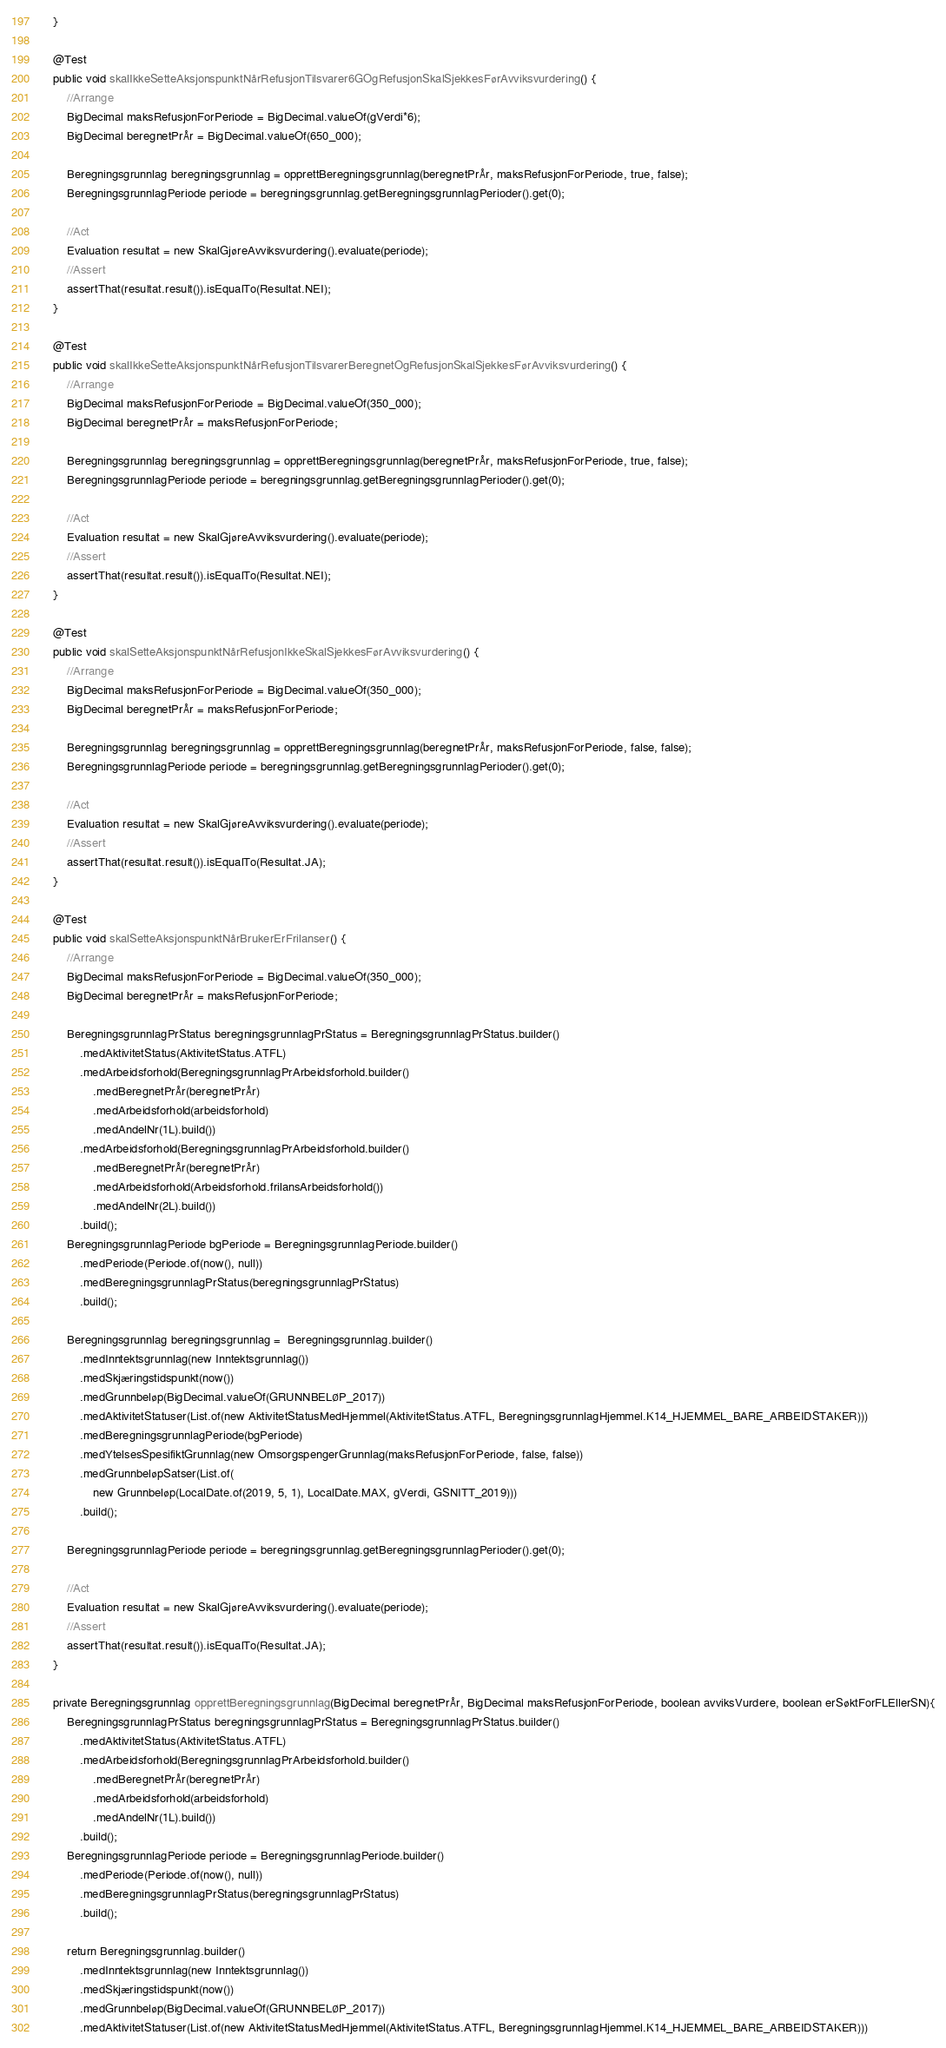<code> <loc_0><loc_0><loc_500><loc_500><_Java_>    }

    @Test
    public void skalIkkeSetteAksjonspunktNårRefusjonTilsvarer6GOgRefusjonSkalSjekkesFørAvviksvurdering() {
        //Arrange
        BigDecimal maksRefusjonForPeriode = BigDecimal.valueOf(gVerdi*6);
        BigDecimal beregnetPrÅr = BigDecimal.valueOf(650_000);

        Beregningsgrunnlag beregningsgrunnlag = opprettBeregningsgrunnlag(beregnetPrÅr, maksRefusjonForPeriode, true, false);
        BeregningsgrunnlagPeriode periode = beregningsgrunnlag.getBeregningsgrunnlagPerioder().get(0);

        //Act
        Evaluation resultat = new SkalGjøreAvviksvurdering().evaluate(periode);
        //Assert
        assertThat(resultat.result()).isEqualTo(Resultat.NEI);
    }

    @Test
    public void skalIkkeSetteAksjonspunktNårRefusjonTilsvarerBeregnetOgRefusjonSkalSjekkesFørAvviksvurdering() {
        //Arrange
        BigDecimal maksRefusjonForPeriode = BigDecimal.valueOf(350_000);
        BigDecimal beregnetPrÅr = maksRefusjonForPeriode;

        Beregningsgrunnlag beregningsgrunnlag = opprettBeregningsgrunnlag(beregnetPrÅr, maksRefusjonForPeriode, true, false);
        BeregningsgrunnlagPeriode periode = beregningsgrunnlag.getBeregningsgrunnlagPerioder().get(0);

        //Act
        Evaluation resultat = new SkalGjøreAvviksvurdering().evaluate(periode);
        //Assert
        assertThat(resultat.result()).isEqualTo(Resultat.NEI);
    }

    @Test
    public void skalSetteAksjonspunktNårRefusjonIkkeSkalSjekkesFørAvviksvurdering() {
        //Arrange
        BigDecimal maksRefusjonForPeriode = BigDecimal.valueOf(350_000);
        BigDecimal beregnetPrÅr = maksRefusjonForPeriode;

        Beregningsgrunnlag beregningsgrunnlag = opprettBeregningsgrunnlag(beregnetPrÅr, maksRefusjonForPeriode, false, false);
        BeregningsgrunnlagPeriode periode = beregningsgrunnlag.getBeregningsgrunnlagPerioder().get(0);

        //Act
        Evaluation resultat = new SkalGjøreAvviksvurdering().evaluate(periode);
        //Assert
        assertThat(resultat.result()).isEqualTo(Resultat.JA);
    }

    @Test
    public void skalSetteAksjonspunktNårBrukerErFrilanser() {
        //Arrange
        BigDecimal maksRefusjonForPeriode = BigDecimal.valueOf(350_000);
        BigDecimal beregnetPrÅr = maksRefusjonForPeriode;

        BeregningsgrunnlagPrStatus beregningsgrunnlagPrStatus = BeregningsgrunnlagPrStatus.builder()
            .medAktivitetStatus(AktivitetStatus.ATFL)
            .medArbeidsforhold(BeregningsgrunnlagPrArbeidsforhold.builder()
                .medBeregnetPrÅr(beregnetPrÅr)
                .medArbeidsforhold(arbeidsforhold)
                .medAndelNr(1L).build())
            .medArbeidsforhold(BeregningsgrunnlagPrArbeidsforhold.builder()
                .medBeregnetPrÅr(beregnetPrÅr)
                .medArbeidsforhold(Arbeidsforhold.frilansArbeidsforhold())
                .medAndelNr(2L).build())
            .build();
        BeregningsgrunnlagPeriode bgPeriode = BeregningsgrunnlagPeriode.builder()
            .medPeriode(Periode.of(now(), null))
            .medBeregningsgrunnlagPrStatus(beregningsgrunnlagPrStatus)
            .build();

        Beregningsgrunnlag beregningsgrunnlag =  Beregningsgrunnlag.builder()
            .medInntektsgrunnlag(new Inntektsgrunnlag())
            .medSkjæringstidspunkt(now())
            .medGrunnbeløp(BigDecimal.valueOf(GRUNNBELØP_2017))
            .medAktivitetStatuser(List.of(new AktivitetStatusMedHjemmel(AktivitetStatus.ATFL, BeregningsgrunnlagHjemmel.K14_HJEMMEL_BARE_ARBEIDSTAKER)))
            .medBeregningsgrunnlagPeriode(bgPeriode)
            .medYtelsesSpesifiktGrunnlag(new OmsorgspengerGrunnlag(maksRefusjonForPeriode, false, false))
            .medGrunnbeløpSatser(List.of(
                new Grunnbeløp(LocalDate.of(2019, 5, 1), LocalDate.MAX, gVerdi, GSNITT_2019)))
            .build();

        BeregningsgrunnlagPeriode periode = beregningsgrunnlag.getBeregningsgrunnlagPerioder().get(0);

        //Act
        Evaluation resultat = new SkalGjøreAvviksvurdering().evaluate(periode);
        //Assert
        assertThat(resultat.result()).isEqualTo(Resultat.JA);
    }

    private Beregningsgrunnlag opprettBeregningsgrunnlag(BigDecimal beregnetPrÅr, BigDecimal maksRefusjonForPeriode, boolean avviksVurdere, boolean erSøktForFLEllerSN){
        BeregningsgrunnlagPrStatus beregningsgrunnlagPrStatus = BeregningsgrunnlagPrStatus.builder()
            .medAktivitetStatus(AktivitetStatus.ATFL)
            .medArbeidsforhold(BeregningsgrunnlagPrArbeidsforhold.builder()
                .medBeregnetPrÅr(beregnetPrÅr)
                .medArbeidsforhold(arbeidsforhold)
                .medAndelNr(1L).build())
            .build();
        BeregningsgrunnlagPeriode periode = BeregningsgrunnlagPeriode.builder()
            .medPeriode(Periode.of(now(), null))
            .medBeregningsgrunnlagPrStatus(beregningsgrunnlagPrStatus)
            .build();

        return Beregningsgrunnlag.builder()
            .medInntektsgrunnlag(new Inntektsgrunnlag())
            .medSkjæringstidspunkt(now())
            .medGrunnbeløp(BigDecimal.valueOf(GRUNNBELØP_2017))
            .medAktivitetStatuser(List.of(new AktivitetStatusMedHjemmel(AktivitetStatus.ATFL, BeregningsgrunnlagHjemmel.K14_HJEMMEL_BARE_ARBEIDSTAKER)))</code> 